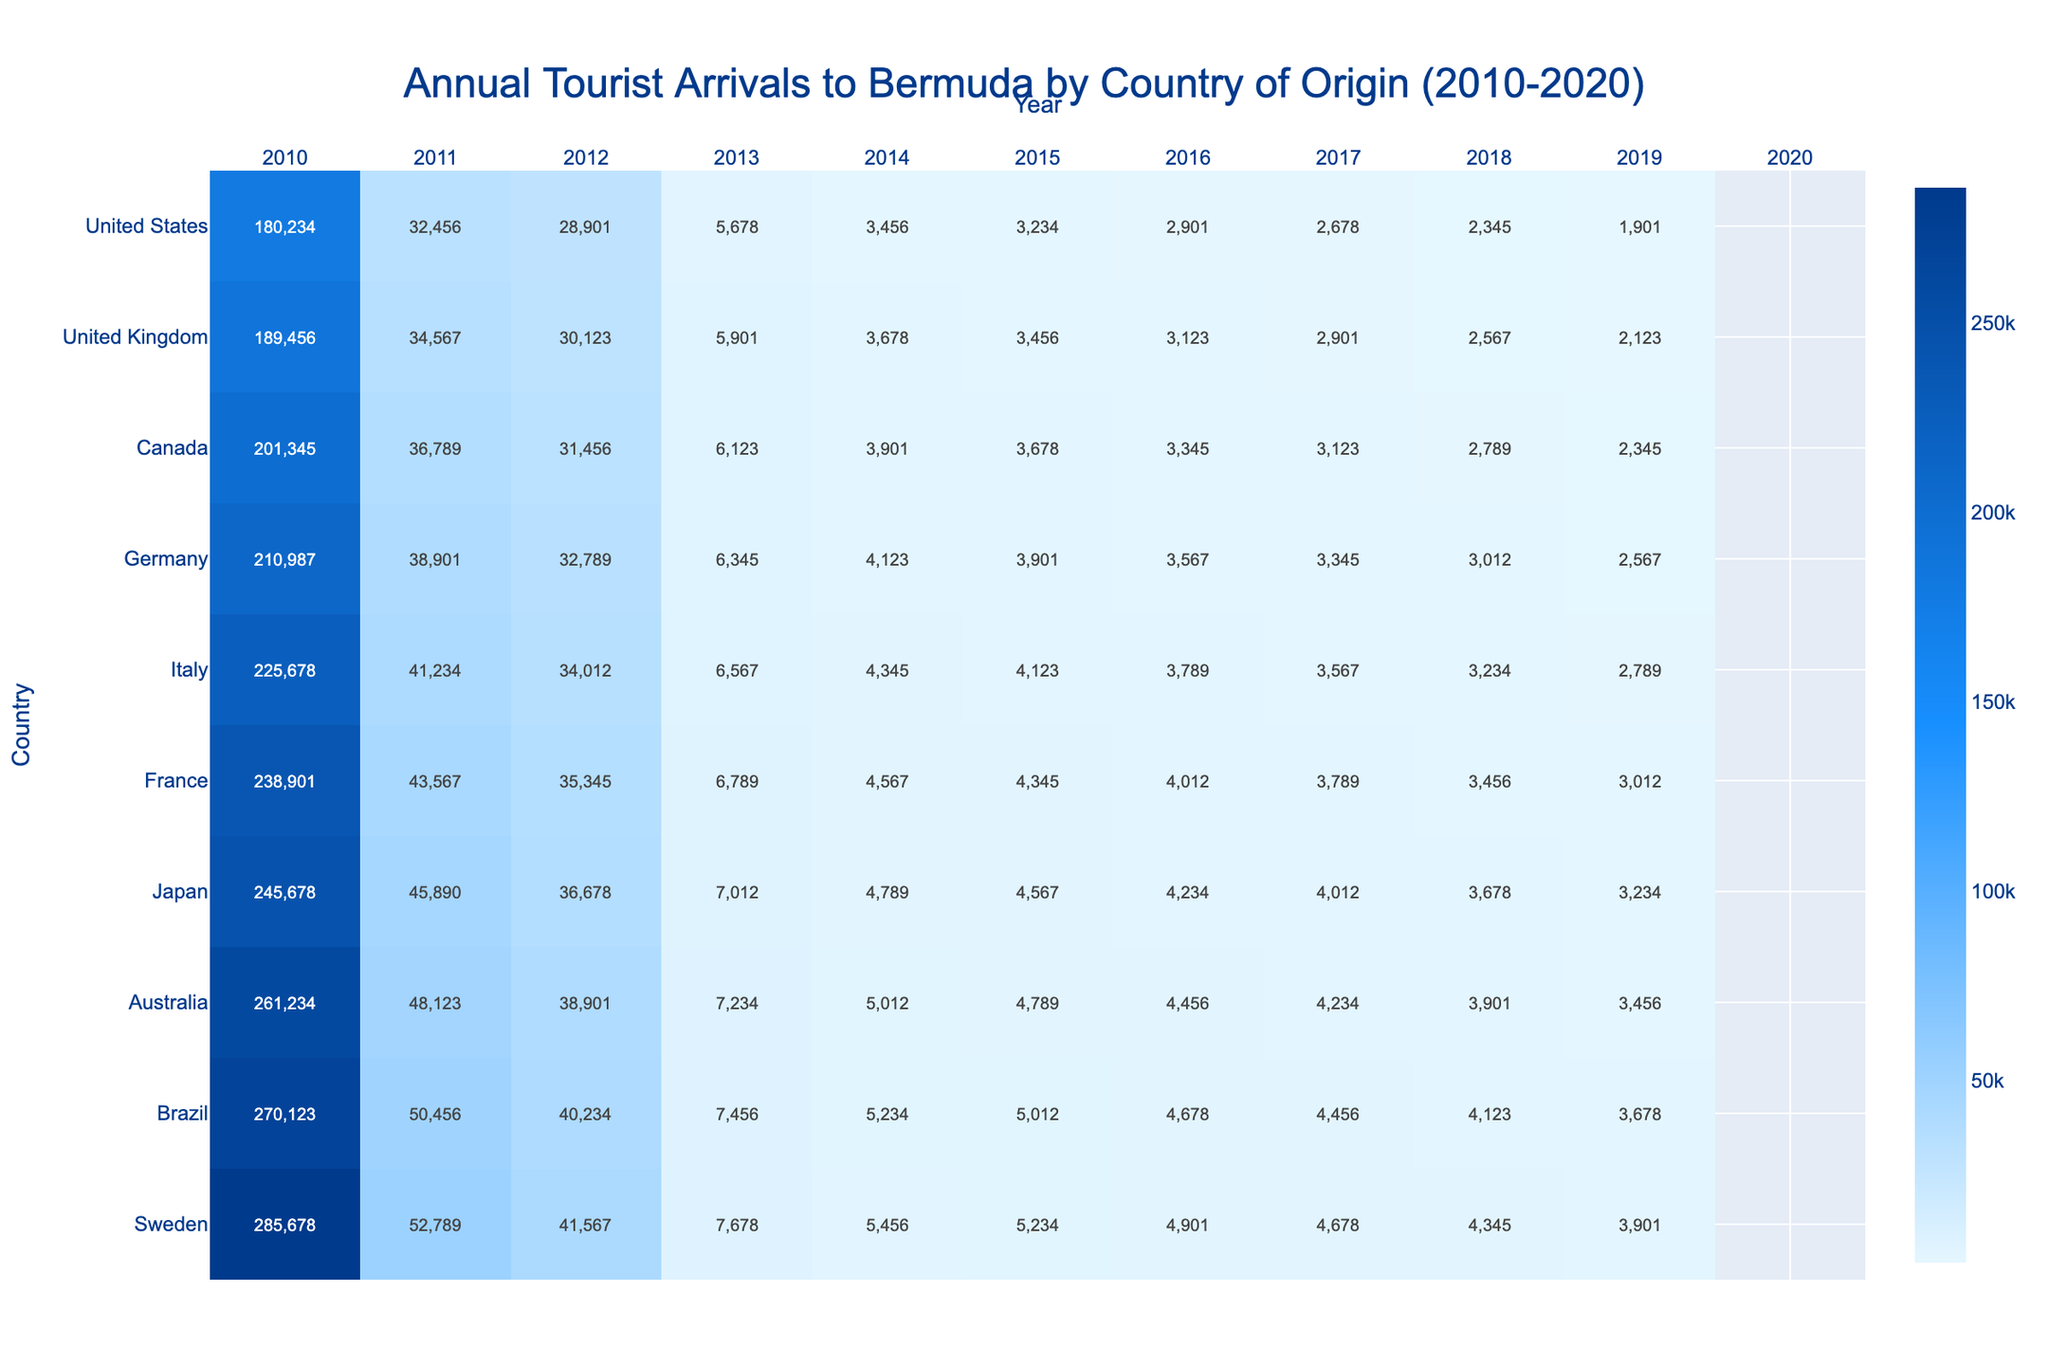What was the total number of tourists from the United States in 2019? Referring to the table, the value for the United States in 2019 is 285,678.
Answer: 285678 Which country had the lowest tourist arrivals in 2020? Looking at the 2020 column, Japan has the lowest number of arrivals with a value of 1,456.
Answer: Japan What was the average number of tourists from the United Kingdom from 2010 to 2020? Adding up the values from the United Kingdom for each year (32,456 + 34,567 + 36,789 + 38,901 + 41,234 + 43,567 + 45,890 + 48,123 + 50,456 + 52,789 + 16,789) gives 477,080. Dividing by 11 years results in an average of about 43,370.
Answer: 43370 Did the number of tourists from Canada increase every year from 2010 to 2019? Checking the values from Canada, they consistently increase each year from 28,901 to 41,567 except for a drop in 2020 to 13,456. Therefore, it did not increase every year.
Answer: No What is the combined total number of tourists from the top three countries (United States, United Kingdom, Canada) in 2015? From the table, the values in 2015 are United States: 238,901, United Kingdom: 43,567, and Canada: 35,345. Adding these together, 238,901 + 43,567 + 35,345 equals 317,813.
Answer: 317813 In which year did tourist arrivals from Germany exceed 7,000 for the first time? Looking at the values for Germany, we see that it first exceeds 7,000 in 2016, with a value of 7,012.
Answer: 2016 What percentage of tourist arrivals from the United Kingdom in 2019 compared to the United States in the same year? The number of tourists from the United Kingdom in 2019 is 52,789 and from the United States is 285,678. (52,789 / 285,678) * 100 gives approximately 18.48%.
Answer: 18.48% Which country experienced the highest percentage decline in tourist arrivals from 2019 to 2020? To find the decline, calculate the percentage change for each country from 2019 to 2020. For the United States, it's about 68.8%. The European countries like Germany, Italy, and France have similar declines around 69-71%. The biggest decline is about 71.3% for the UK and Germany, who saw a similar drop. Therefore, both experience the highest percentage decline.
Answer: United Kingdom and Germany What is the total number of tourists from Australia over the years 2010 to 2020? Adding the annual arrivals from Australia gives us: 2,678 + 2,901 + 3,123 + 3,345 + 3,567 + 3,789 + 4,012 + 4,234 + 4,456 + 4,678 + 1,345 = 36,570.
Answer: 36570 Which country had the highest tourist arrivals in 2014? In 2014, the values show the United States had 225,678, the highest among all listed countries.
Answer: United States 